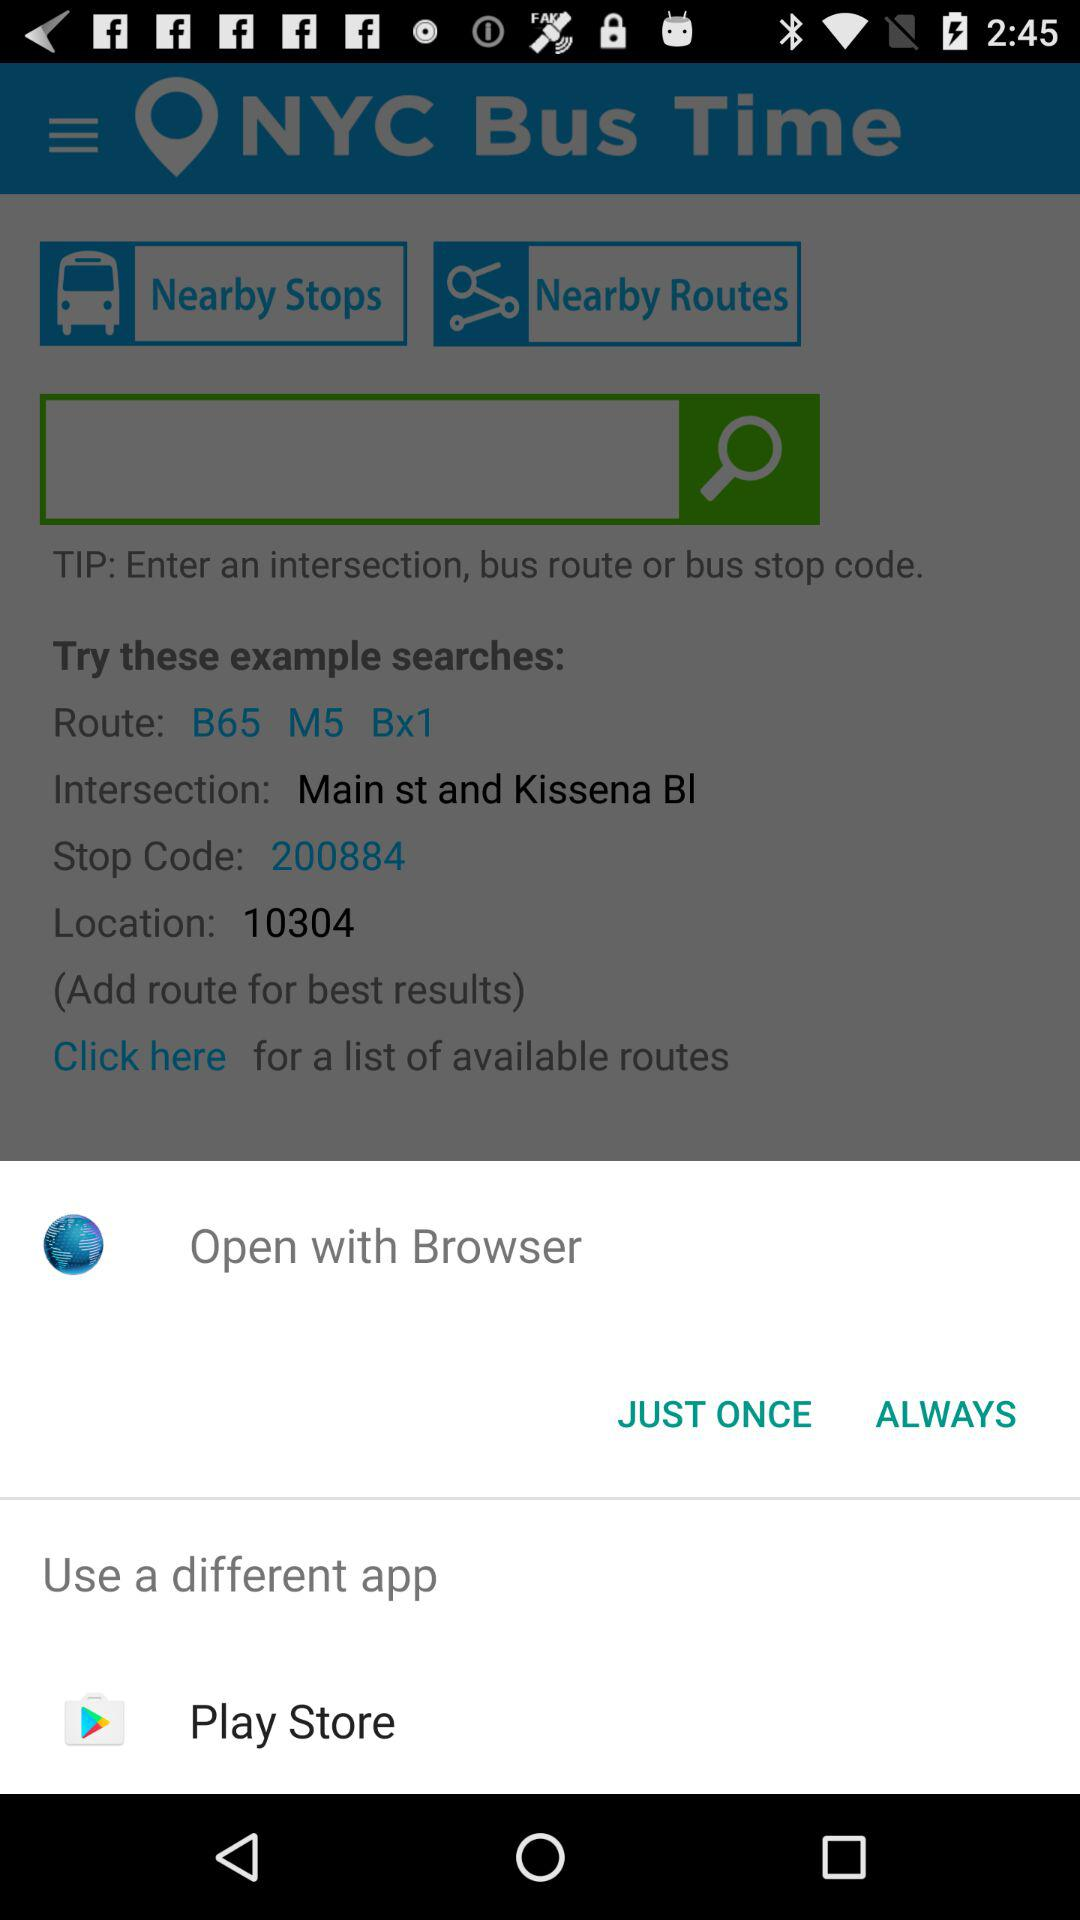What is the name of the application? The name of the application is "NYC Bus Time". 